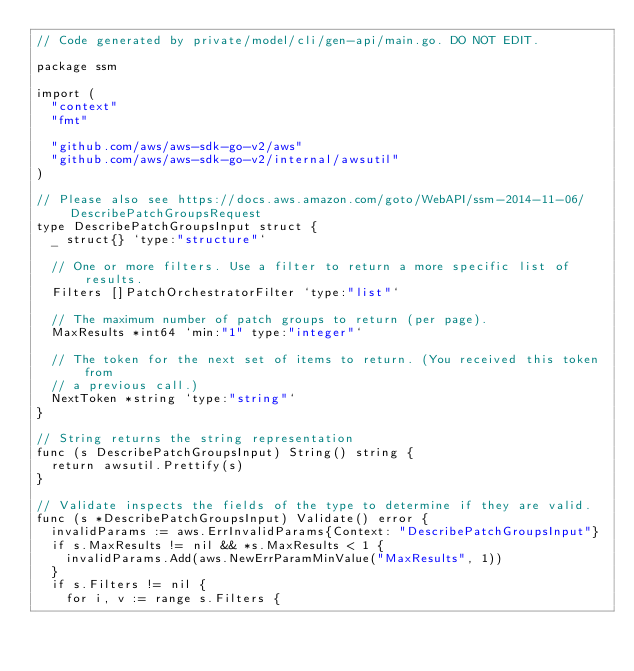<code> <loc_0><loc_0><loc_500><loc_500><_Go_>// Code generated by private/model/cli/gen-api/main.go. DO NOT EDIT.

package ssm

import (
	"context"
	"fmt"

	"github.com/aws/aws-sdk-go-v2/aws"
	"github.com/aws/aws-sdk-go-v2/internal/awsutil"
)

// Please also see https://docs.aws.amazon.com/goto/WebAPI/ssm-2014-11-06/DescribePatchGroupsRequest
type DescribePatchGroupsInput struct {
	_ struct{} `type:"structure"`

	// One or more filters. Use a filter to return a more specific list of results.
	Filters []PatchOrchestratorFilter `type:"list"`

	// The maximum number of patch groups to return (per page).
	MaxResults *int64 `min:"1" type:"integer"`

	// The token for the next set of items to return. (You received this token from
	// a previous call.)
	NextToken *string `type:"string"`
}

// String returns the string representation
func (s DescribePatchGroupsInput) String() string {
	return awsutil.Prettify(s)
}

// Validate inspects the fields of the type to determine if they are valid.
func (s *DescribePatchGroupsInput) Validate() error {
	invalidParams := aws.ErrInvalidParams{Context: "DescribePatchGroupsInput"}
	if s.MaxResults != nil && *s.MaxResults < 1 {
		invalidParams.Add(aws.NewErrParamMinValue("MaxResults", 1))
	}
	if s.Filters != nil {
		for i, v := range s.Filters {</code> 